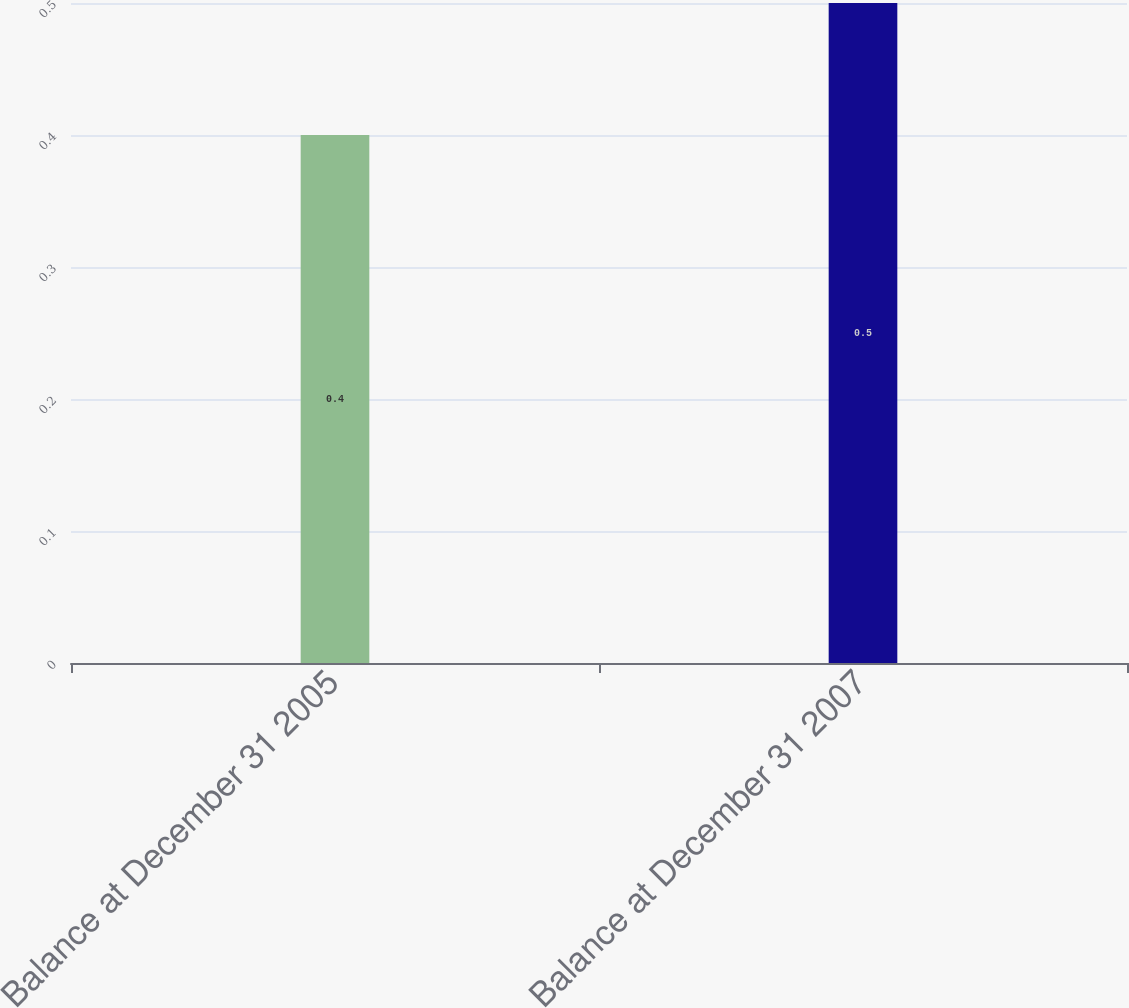Convert chart to OTSL. <chart><loc_0><loc_0><loc_500><loc_500><bar_chart><fcel>Balance at December 31 2005<fcel>Balance at December 31 2007<nl><fcel>0.4<fcel>0.5<nl></chart> 